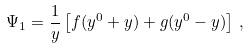<formula> <loc_0><loc_0><loc_500><loc_500>\Psi _ { 1 } = \frac { 1 } { y } \left [ f ( y ^ { 0 } + y ) + g ( y ^ { 0 } - y ) \right ] \, ,</formula> 